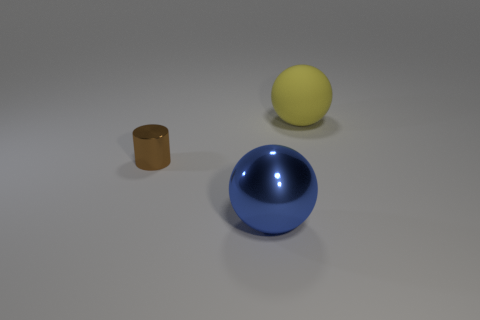Subtract all cylinders. How many objects are left? 2 Subtract 1 cylinders. How many cylinders are left? 0 Subtract all blue cubes. How many purple cylinders are left? 0 Add 1 big red matte blocks. How many objects exist? 4 Subtract 1 brown cylinders. How many objects are left? 2 Subtract all brown spheres. Subtract all blue cubes. How many spheres are left? 2 Subtract all small brown metallic cylinders. Subtract all blue things. How many objects are left? 1 Add 2 big shiny objects. How many big shiny objects are left? 3 Add 3 yellow objects. How many yellow objects exist? 4 